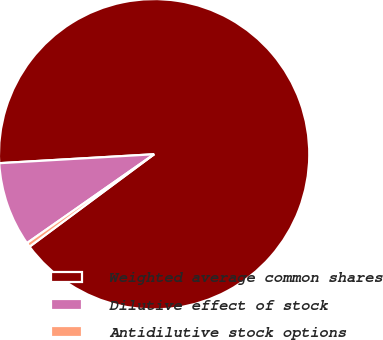Convert chart. <chart><loc_0><loc_0><loc_500><loc_500><pie_chart><fcel>Weighted average common shares<fcel>Dilutive effect of stock<fcel>Antidilutive stock options<nl><fcel>90.76%<fcel>8.79%<fcel>0.45%<nl></chart> 